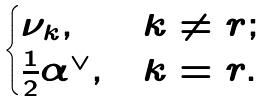Convert formula to latex. <formula><loc_0><loc_0><loc_500><loc_500>\begin{cases} \nu _ { k } , & k \neq r ; \\ \frac { 1 } { 2 } \alpha ^ { \vee } , & k = r . \end{cases}</formula> 